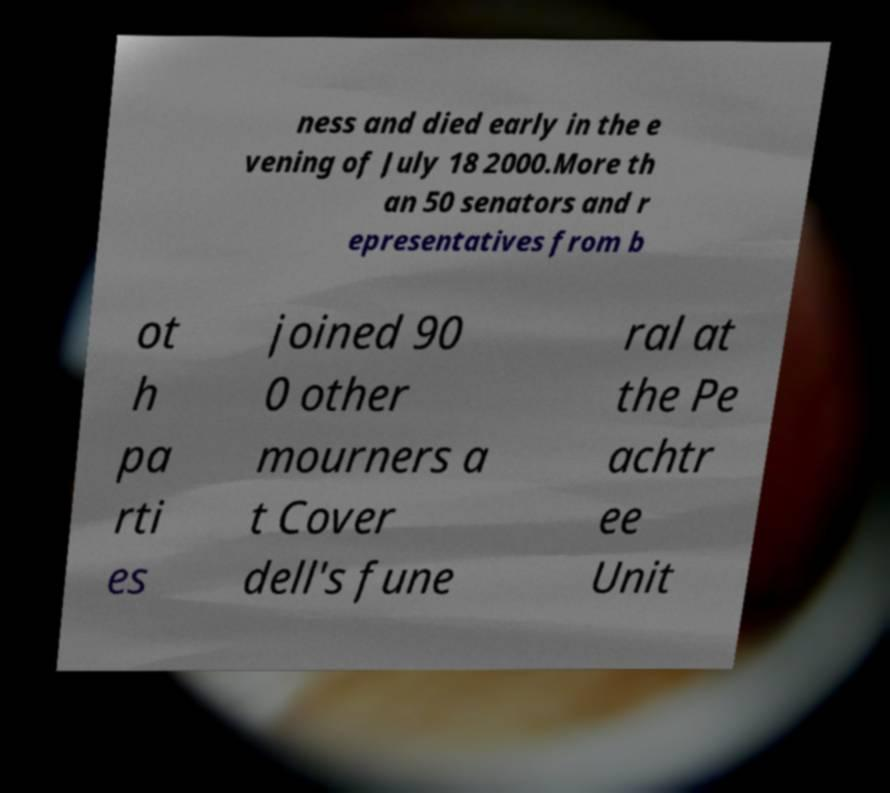Could you extract and type out the text from this image? ness and died early in the e vening of July 18 2000.More th an 50 senators and r epresentatives from b ot h pa rti es joined 90 0 other mourners a t Cover dell's fune ral at the Pe achtr ee Unit 